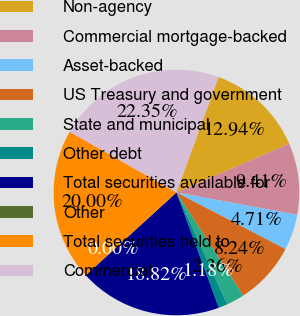Convert chart to OTSL. <chart><loc_0><loc_0><loc_500><loc_500><pie_chart><fcel>Non-agency<fcel>Commercial mortgage-backed<fcel>Asset-backed<fcel>US Treasury and government<fcel>State and municipal<fcel>Other debt<fcel>Total securities available for<fcel>Other<fcel>Total securities held to<fcel>Commercial<nl><fcel>12.94%<fcel>9.41%<fcel>4.71%<fcel>8.24%<fcel>2.36%<fcel>1.18%<fcel>18.82%<fcel>0.0%<fcel>20.0%<fcel>22.35%<nl></chart> 